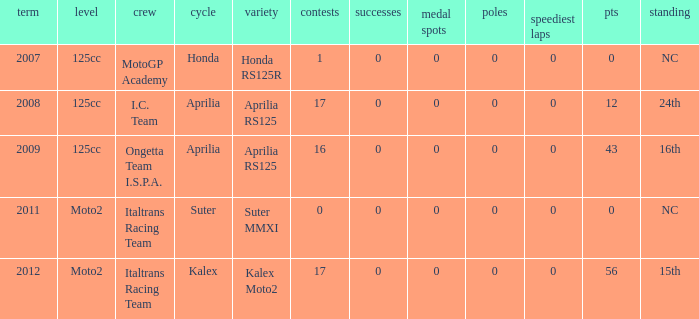What's the name of the team who had a Honda motorcycle? MotoGP Academy. 